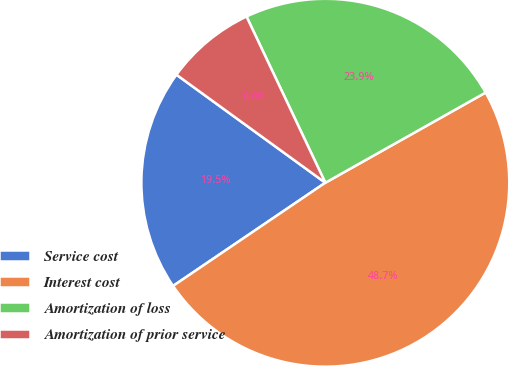<chart> <loc_0><loc_0><loc_500><loc_500><pie_chart><fcel>Service cost<fcel>Interest cost<fcel>Amortization of loss<fcel>Amortization of prior service<nl><fcel>19.47%<fcel>48.67%<fcel>23.89%<fcel>7.96%<nl></chart> 